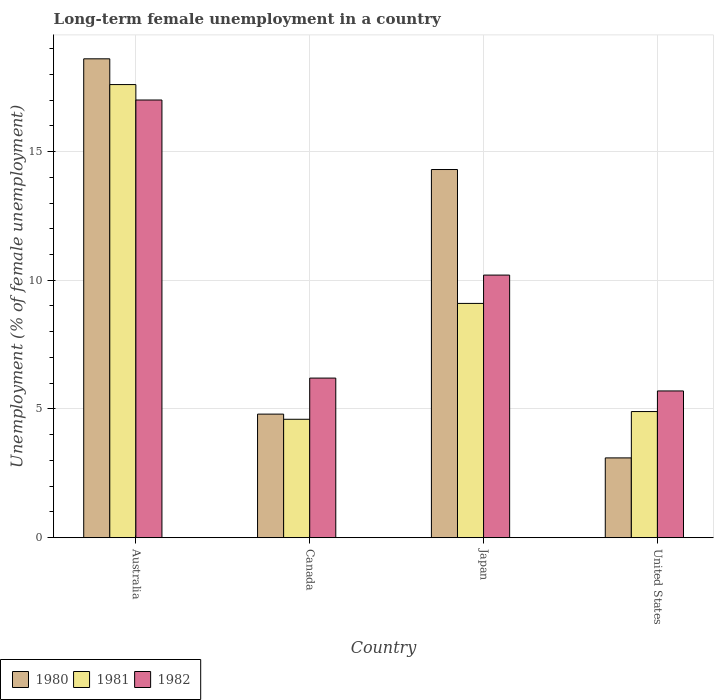Are the number of bars per tick equal to the number of legend labels?
Provide a short and direct response. Yes. Are the number of bars on each tick of the X-axis equal?
Ensure brevity in your answer.  Yes. In how many cases, is the number of bars for a given country not equal to the number of legend labels?
Keep it short and to the point. 0. What is the percentage of long-term unemployed female population in 1982 in United States?
Provide a succinct answer. 5.7. Across all countries, what is the maximum percentage of long-term unemployed female population in 1981?
Give a very brief answer. 17.6. Across all countries, what is the minimum percentage of long-term unemployed female population in 1981?
Offer a terse response. 4.6. In which country was the percentage of long-term unemployed female population in 1981 maximum?
Your response must be concise. Australia. In which country was the percentage of long-term unemployed female population in 1981 minimum?
Ensure brevity in your answer.  Canada. What is the total percentage of long-term unemployed female population in 1980 in the graph?
Provide a short and direct response. 40.8. What is the difference between the percentage of long-term unemployed female population in 1980 in Japan and that in United States?
Make the answer very short. 11.2. What is the difference between the percentage of long-term unemployed female population in 1980 in Australia and the percentage of long-term unemployed female population in 1982 in United States?
Offer a very short reply. 12.9. What is the average percentage of long-term unemployed female population in 1982 per country?
Ensure brevity in your answer.  9.77. What is the difference between the percentage of long-term unemployed female population of/in 1981 and percentage of long-term unemployed female population of/in 1982 in United States?
Make the answer very short. -0.8. What is the ratio of the percentage of long-term unemployed female population in 1981 in Canada to that in United States?
Give a very brief answer. 0.94. Is the difference between the percentage of long-term unemployed female population in 1981 in Canada and Japan greater than the difference between the percentage of long-term unemployed female population in 1982 in Canada and Japan?
Your answer should be very brief. No. What is the difference between the highest and the second highest percentage of long-term unemployed female population in 1982?
Keep it short and to the point. 6.8. What is the difference between the highest and the lowest percentage of long-term unemployed female population in 1981?
Your answer should be compact. 13. What does the 2nd bar from the left in United States represents?
Offer a very short reply. 1981. What does the 1st bar from the right in United States represents?
Give a very brief answer. 1982. How many countries are there in the graph?
Your response must be concise. 4. What is the difference between two consecutive major ticks on the Y-axis?
Offer a terse response. 5. What is the title of the graph?
Offer a terse response. Long-term female unemployment in a country. What is the label or title of the X-axis?
Your response must be concise. Country. What is the label or title of the Y-axis?
Your answer should be very brief. Unemployment (% of female unemployment). What is the Unemployment (% of female unemployment) in 1980 in Australia?
Keep it short and to the point. 18.6. What is the Unemployment (% of female unemployment) in 1981 in Australia?
Give a very brief answer. 17.6. What is the Unemployment (% of female unemployment) in 1980 in Canada?
Make the answer very short. 4.8. What is the Unemployment (% of female unemployment) in 1981 in Canada?
Your answer should be compact. 4.6. What is the Unemployment (% of female unemployment) in 1982 in Canada?
Give a very brief answer. 6.2. What is the Unemployment (% of female unemployment) in 1980 in Japan?
Offer a terse response. 14.3. What is the Unemployment (% of female unemployment) of 1981 in Japan?
Your response must be concise. 9.1. What is the Unemployment (% of female unemployment) of 1982 in Japan?
Give a very brief answer. 10.2. What is the Unemployment (% of female unemployment) in 1980 in United States?
Your answer should be compact. 3.1. What is the Unemployment (% of female unemployment) in 1981 in United States?
Ensure brevity in your answer.  4.9. What is the Unemployment (% of female unemployment) in 1982 in United States?
Your answer should be compact. 5.7. Across all countries, what is the maximum Unemployment (% of female unemployment) in 1980?
Your response must be concise. 18.6. Across all countries, what is the maximum Unemployment (% of female unemployment) of 1981?
Offer a very short reply. 17.6. Across all countries, what is the minimum Unemployment (% of female unemployment) of 1980?
Your response must be concise. 3.1. Across all countries, what is the minimum Unemployment (% of female unemployment) of 1981?
Your response must be concise. 4.6. Across all countries, what is the minimum Unemployment (% of female unemployment) in 1982?
Provide a short and direct response. 5.7. What is the total Unemployment (% of female unemployment) in 1980 in the graph?
Offer a very short reply. 40.8. What is the total Unemployment (% of female unemployment) of 1981 in the graph?
Provide a succinct answer. 36.2. What is the total Unemployment (% of female unemployment) of 1982 in the graph?
Your response must be concise. 39.1. What is the difference between the Unemployment (% of female unemployment) of 1980 in Australia and that in United States?
Your response must be concise. 15.5. What is the difference between the Unemployment (% of female unemployment) in 1981 in Australia and that in United States?
Make the answer very short. 12.7. What is the difference between the Unemployment (% of female unemployment) of 1980 in Canada and that in Japan?
Provide a short and direct response. -9.5. What is the difference between the Unemployment (% of female unemployment) of 1980 in Japan and that in United States?
Your answer should be very brief. 11.2. What is the difference between the Unemployment (% of female unemployment) in 1981 in Japan and that in United States?
Offer a terse response. 4.2. What is the difference between the Unemployment (% of female unemployment) of 1982 in Japan and that in United States?
Offer a very short reply. 4.5. What is the difference between the Unemployment (% of female unemployment) in 1980 in Australia and the Unemployment (% of female unemployment) in 1982 in Canada?
Provide a succinct answer. 12.4. What is the difference between the Unemployment (% of female unemployment) of 1980 in Australia and the Unemployment (% of female unemployment) of 1982 in Japan?
Provide a short and direct response. 8.4. What is the difference between the Unemployment (% of female unemployment) of 1981 in Australia and the Unemployment (% of female unemployment) of 1982 in Japan?
Ensure brevity in your answer.  7.4. What is the difference between the Unemployment (% of female unemployment) in 1980 in Australia and the Unemployment (% of female unemployment) in 1981 in United States?
Give a very brief answer. 13.7. What is the difference between the Unemployment (% of female unemployment) in 1981 in Australia and the Unemployment (% of female unemployment) in 1982 in United States?
Offer a very short reply. 11.9. What is the difference between the Unemployment (% of female unemployment) in 1980 in Canada and the Unemployment (% of female unemployment) in 1981 in Japan?
Ensure brevity in your answer.  -4.3. What is the difference between the Unemployment (% of female unemployment) in 1980 in Canada and the Unemployment (% of female unemployment) in 1982 in Japan?
Your answer should be compact. -5.4. What is the difference between the Unemployment (% of female unemployment) of 1981 in Canada and the Unemployment (% of female unemployment) of 1982 in Japan?
Keep it short and to the point. -5.6. What is the difference between the Unemployment (% of female unemployment) of 1980 in Canada and the Unemployment (% of female unemployment) of 1982 in United States?
Make the answer very short. -0.9. What is the difference between the Unemployment (% of female unemployment) in 1981 in Canada and the Unemployment (% of female unemployment) in 1982 in United States?
Provide a short and direct response. -1.1. What is the average Unemployment (% of female unemployment) in 1981 per country?
Provide a short and direct response. 9.05. What is the average Unemployment (% of female unemployment) in 1982 per country?
Provide a succinct answer. 9.78. What is the difference between the Unemployment (% of female unemployment) of 1980 and Unemployment (% of female unemployment) of 1982 in Australia?
Offer a very short reply. 1.6. What is the difference between the Unemployment (% of female unemployment) of 1980 and Unemployment (% of female unemployment) of 1981 in Canada?
Your response must be concise. 0.2. What is the difference between the Unemployment (% of female unemployment) of 1980 and Unemployment (% of female unemployment) of 1981 in United States?
Provide a short and direct response. -1.8. What is the difference between the Unemployment (% of female unemployment) in 1980 and Unemployment (% of female unemployment) in 1982 in United States?
Provide a short and direct response. -2.6. What is the ratio of the Unemployment (% of female unemployment) in 1980 in Australia to that in Canada?
Your response must be concise. 3.88. What is the ratio of the Unemployment (% of female unemployment) of 1981 in Australia to that in Canada?
Provide a succinct answer. 3.83. What is the ratio of the Unemployment (% of female unemployment) in 1982 in Australia to that in Canada?
Provide a short and direct response. 2.74. What is the ratio of the Unemployment (% of female unemployment) of 1980 in Australia to that in Japan?
Offer a terse response. 1.3. What is the ratio of the Unemployment (% of female unemployment) in 1981 in Australia to that in Japan?
Your answer should be very brief. 1.93. What is the ratio of the Unemployment (% of female unemployment) of 1982 in Australia to that in Japan?
Offer a terse response. 1.67. What is the ratio of the Unemployment (% of female unemployment) in 1980 in Australia to that in United States?
Your answer should be compact. 6. What is the ratio of the Unemployment (% of female unemployment) of 1981 in Australia to that in United States?
Offer a terse response. 3.59. What is the ratio of the Unemployment (% of female unemployment) in 1982 in Australia to that in United States?
Your response must be concise. 2.98. What is the ratio of the Unemployment (% of female unemployment) of 1980 in Canada to that in Japan?
Your response must be concise. 0.34. What is the ratio of the Unemployment (% of female unemployment) in 1981 in Canada to that in Japan?
Offer a terse response. 0.51. What is the ratio of the Unemployment (% of female unemployment) in 1982 in Canada to that in Japan?
Keep it short and to the point. 0.61. What is the ratio of the Unemployment (% of female unemployment) of 1980 in Canada to that in United States?
Ensure brevity in your answer.  1.55. What is the ratio of the Unemployment (% of female unemployment) in 1981 in Canada to that in United States?
Provide a succinct answer. 0.94. What is the ratio of the Unemployment (% of female unemployment) in 1982 in Canada to that in United States?
Offer a very short reply. 1.09. What is the ratio of the Unemployment (% of female unemployment) of 1980 in Japan to that in United States?
Your answer should be compact. 4.61. What is the ratio of the Unemployment (% of female unemployment) of 1981 in Japan to that in United States?
Give a very brief answer. 1.86. What is the ratio of the Unemployment (% of female unemployment) of 1982 in Japan to that in United States?
Keep it short and to the point. 1.79. What is the difference between the highest and the second highest Unemployment (% of female unemployment) in 1981?
Your response must be concise. 8.5. What is the difference between the highest and the lowest Unemployment (% of female unemployment) of 1980?
Your response must be concise. 15.5. 